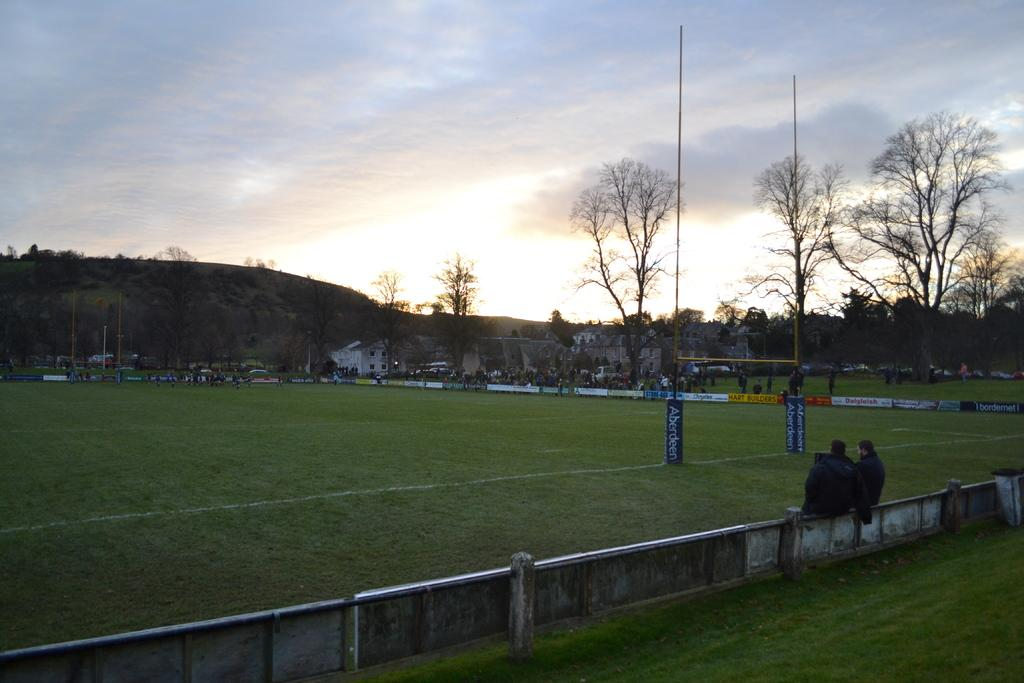How many people are in the image? There are two persons in the image. What type of vegetation is present in the image? There is grass in the image. What structures can be seen in the image? There are poles, boards, and houses in the image. What type of natural elements are visible in the image? There are trees in the image. What part of the natural environment is visible in the background of the image? The sky is visible in the background of the image. How does the pest use the comb in the image? There is no pest or comb present in the image. 